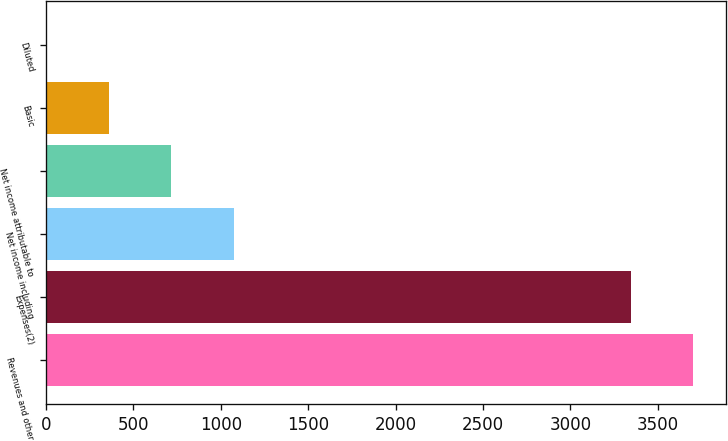Convert chart to OTSL. <chart><loc_0><loc_0><loc_500><loc_500><bar_chart><fcel>Revenues and other<fcel>Expenses(2)<fcel>Net income including<fcel>Net income attributable to<fcel>Basic<fcel>Diluted<nl><fcel>3703.56<fcel>3346<fcel>1073.11<fcel>715.55<fcel>357.99<fcel>0.43<nl></chart> 